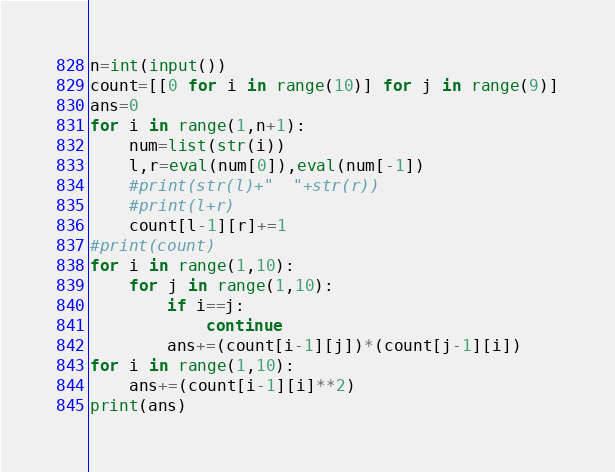Convert code to text. <code><loc_0><loc_0><loc_500><loc_500><_Python_>n=int(input())
count=[[0 for i in range(10)] for j in range(9)]
ans=0
for i in range(1,n+1):
    num=list(str(i))
    l,r=eval(num[0]),eval(num[-1])
    #print(str(l)+"  "+str(r))
    #print(l+r)
    count[l-1][r]+=1
#print(count)
for i in range(1,10):
    for j in range(1,10):
        if i==j:
            continue
        ans+=(count[i-1][j])*(count[j-1][i])
for i in range(1,10):
    ans+=(count[i-1][i]**2)
print(ans)</code> 